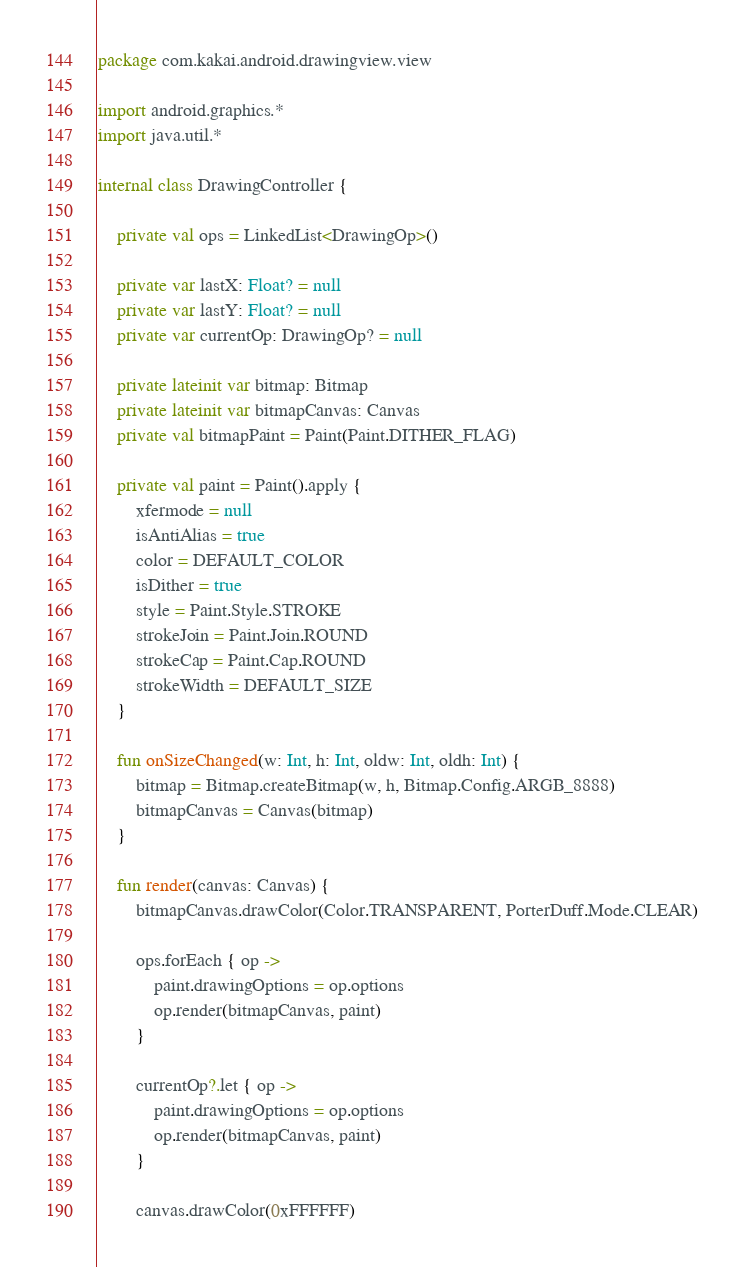<code> <loc_0><loc_0><loc_500><loc_500><_Kotlin_>package com.kakai.android.drawingview.view

import android.graphics.*
import java.util.*

internal class DrawingController {

    private val ops = LinkedList<DrawingOp>()

    private var lastX: Float? = null
    private var lastY: Float? = null
    private var currentOp: DrawingOp? = null

    private lateinit var bitmap: Bitmap
    private lateinit var bitmapCanvas: Canvas
    private val bitmapPaint = Paint(Paint.DITHER_FLAG)

    private val paint = Paint().apply {
        xfermode = null
        isAntiAlias = true
        color = DEFAULT_COLOR
        isDither = true
        style = Paint.Style.STROKE
        strokeJoin = Paint.Join.ROUND
        strokeCap = Paint.Cap.ROUND
        strokeWidth = DEFAULT_SIZE
    }

    fun onSizeChanged(w: Int, h: Int, oldw: Int, oldh: Int) {
        bitmap = Bitmap.createBitmap(w, h, Bitmap.Config.ARGB_8888)
        bitmapCanvas = Canvas(bitmap)
    }

    fun render(canvas: Canvas) {
        bitmapCanvas.drawColor(Color.TRANSPARENT, PorterDuff.Mode.CLEAR)

        ops.forEach { op ->
            paint.drawingOptions = op.options
            op.render(bitmapCanvas, paint)
        }

        currentOp?.let { op ->
            paint.drawingOptions = op.options
            op.render(bitmapCanvas, paint)
        }

        canvas.drawColor(0xFFFFFF)</code> 